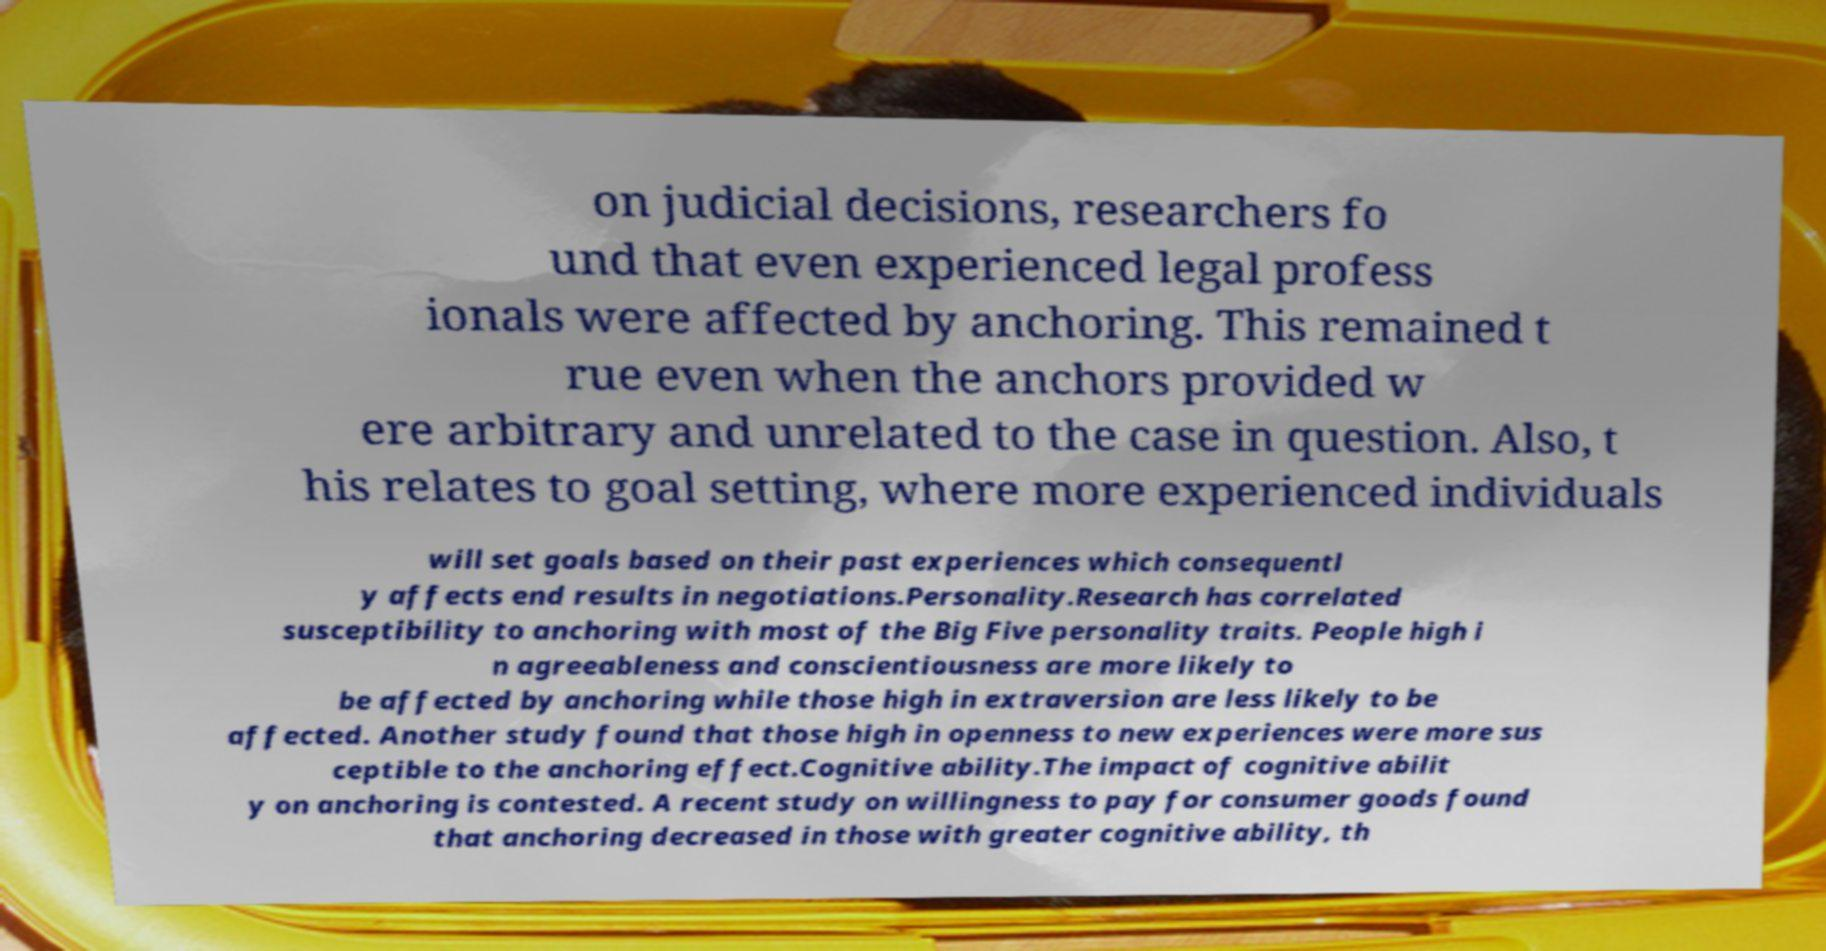Could you extract and type out the text from this image? on judicial decisions, researchers fo und that even experienced legal profess ionals were affected by anchoring. This remained t rue even when the anchors provided w ere arbitrary and unrelated to the case in question. Also, t his relates to goal setting, where more experienced individuals will set goals based on their past experiences which consequentl y affects end results in negotiations.Personality.Research has correlated susceptibility to anchoring with most of the Big Five personality traits. People high i n agreeableness and conscientiousness are more likely to be affected by anchoring while those high in extraversion are less likely to be affected. Another study found that those high in openness to new experiences were more sus ceptible to the anchoring effect.Cognitive ability.The impact of cognitive abilit y on anchoring is contested. A recent study on willingness to pay for consumer goods found that anchoring decreased in those with greater cognitive ability, th 